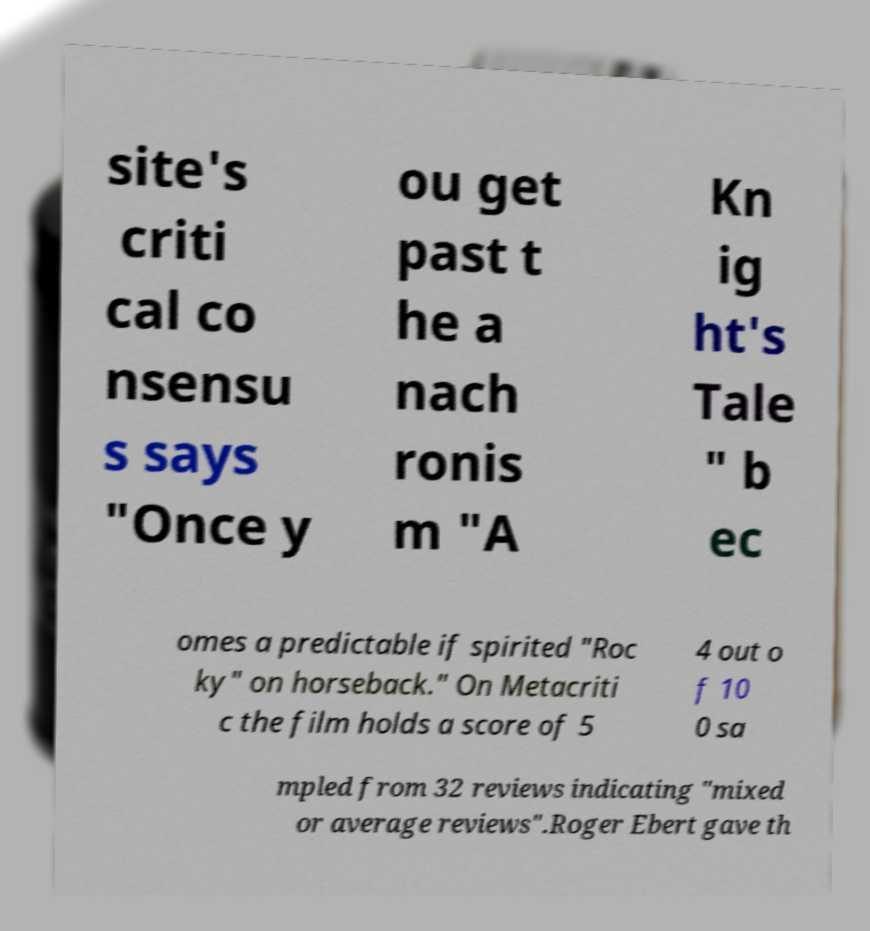For documentation purposes, I need the text within this image transcribed. Could you provide that? site's criti cal co nsensu s says "Once y ou get past t he a nach ronis m "A Kn ig ht's Tale " b ec omes a predictable if spirited "Roc ky" on horseback." On Metacriti c the film holds a score of 5 4 out o f 10 0 sa mpled from 32 reviews indicating "mixed or average reviews".Roger Ebert gave th 